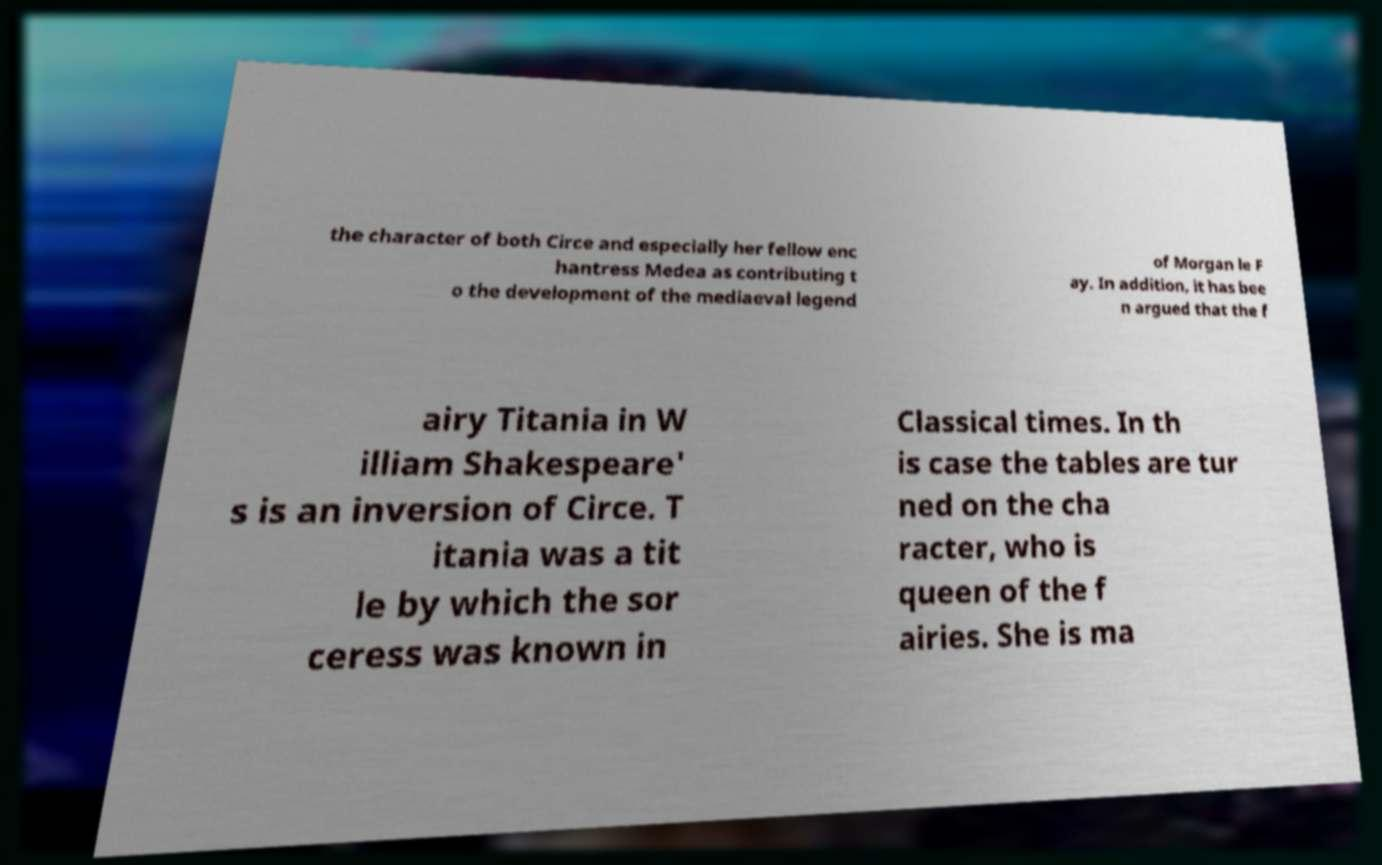Can you read and provide the text displayed in the image?This photo seems to have some interesting text. Can you extract and type it out for me? the character of both Circe and especially her fellow enc hantress Medea as contributing t o the development of the mediaeval legend of Morgan le F ay. In addition, it has bee n argued that the f airy Titania in W illiam Shakespeare' s is an inversion of Circe. T itania was a tit le by which the sor ceress was known in Classical times. In th is case the tables are tur ned on the cha racter, who is queen of the f airies. She is ma 